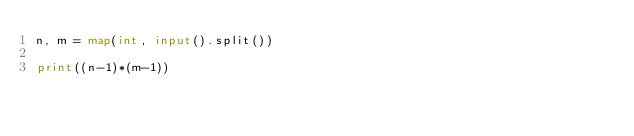<code> <loc_0><loc_0><loc_500><loc_500><_Python_>n, m = map(int, input().split())

print((n-1)*(m-1))</code> 